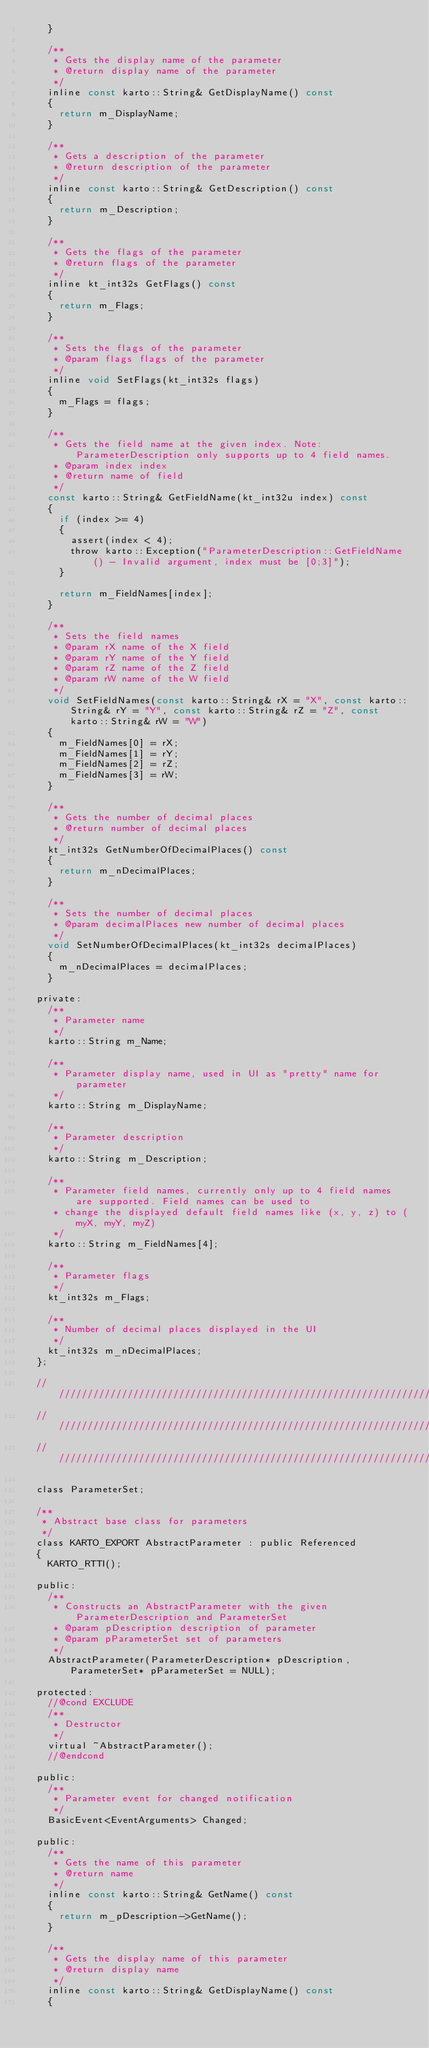Convert code to text. <code><loc_0><loc_0><loc_500><loc_500><_C_>    }

    /**
     * Gets the display name of the parameter
     * @return display name of the parameter
     */
    inline const karto::String& GetDisplayName() const
    {
      return m_DisplayName;
    }

    /**
     * Gets a description of the parameter
     * @return description of the parameter
     */
    inline const karto::String& GetDescription() const
    {
      return m_Description;
    }

    /**
     * Gets the flags of the parameter
     * @return flags of the parameter
     */
    inline kt_int32s GetFlags() const
    {
      return m_Flags;
    }

    /**
     * Sets the flags of the parameter
     * @param flags flags of the parameter
     */
    inline void SetFlags(kt_int32s flags)
    {
      m_Flags = flags;
    }

    /**
     * Gets the field name at the given index. Note: ParameterDescription only supports up to 4 field names.
     * @param index index
     * @return name of field
     */
    const karto::String& GetFieldName(kt_int32u index) const
    {
      if (index >= 4)
      {
        assert(index < 4);
        throw karto::Exception("ParameterDescription::GetFieldName() - Invalid argument, index must be [0;3]");
      }

      return m_FieldNames[index]; 
    }

    /**
     * Sets the field names
     * @param rX name of the X field
     * @param rY name of the Y field
     * @param rZ name of the Z field
     * @param rW name of the W field
     */
    void SetFieldNames(const karto::String& rX = "X", const karto::String& rY = "Y", const karto::String& rZ = "Z", const karto::String& rW = "W") 
    { 
      m_FieldNames[0] = rX; 
      m_FieldNames[1] = rY; 
      m_FieldNames[2] = rZ; 
      m_FieldNames[3] = rW; 
    }

    /**
     * Gets the number of decimal places
     * @return number of decimal places
     */
    kt_int32s GetNumberOfDecimalPlaces() const
    {
      return m_nDecimalPlaces;
    }

    /**
     * Sets the number of decimal places
     * @param decimalPlaces new number of decimal places
     */
    void SetNumberOfDecimalPlaces(kt_int32s decimalPlaces)
    {
      m_nDecimalPlaces = decimalPlaces;
    }

  private:
    /** 
     * Parameter name
     */
    karto::String m_Name;
    
    /**
     * Parameter display name, used in UI as "pretty" name for parameter
     */
    karto::String m_DisplayName;

    /**
     * Parameter description
     */
    karto::String m_Description;

    /**
     * Parameter field names, currently only up to 4 field names are supported. Field names can be used to
     * change the displayed default field names like (x, y, z) to (myX, myY, myZ)
     */
    karto::String m_FieldNames[4];

    /**
     * Parameter flags
     */
    kt_int32s m_Flags;

    /**
     * Number of decimal places displayed in the UI
     */
    kt_int32s m_nDecimalPlaces;
  };

  ////////////////////////////////////////////////////////////////////////////////////////
  ////////////////////////////////////////////////////////////////////////////////////////
  ////////////////////////////////////////////////////////////////////////////////////////

  class ParameterSet;

  /** 
   * Abstract base class for parameters
   */ 
  class KARTO_EXPORT AbstractParameter : public Referenced
  {
    KARTO_RTTI();

  public:
    /**
     * Constructs an AbstractParameter with the given ParameterDescription and ParameterSet
     * @param pDescription description of parameter
     * @param pParameterSet set of parameters
     */
    AbstractParameter(ParameterDescription* pDescription, ParameterSet* pParameterSet = NULL);

  protected:
    //@cond EXCLUDE
    /**
     * Destructor
     */
    virtual ~AbstractParameter();
    //@endcond

  public:
    /**
     * Parameter event for changed notification
     */
    BasicEvent<EventArguments> Changed;

  public:
    /**
     * Gets the name of this parameter
     * @return name
     */
    inline const karto::String& GetName() const
    {
      return m_pDescription->GetName();
    }

    /**
     * Gets the display name of this parameter
     * @return display name
     */
    inline const karto::String& GetDisplayName() const
    {</code> 